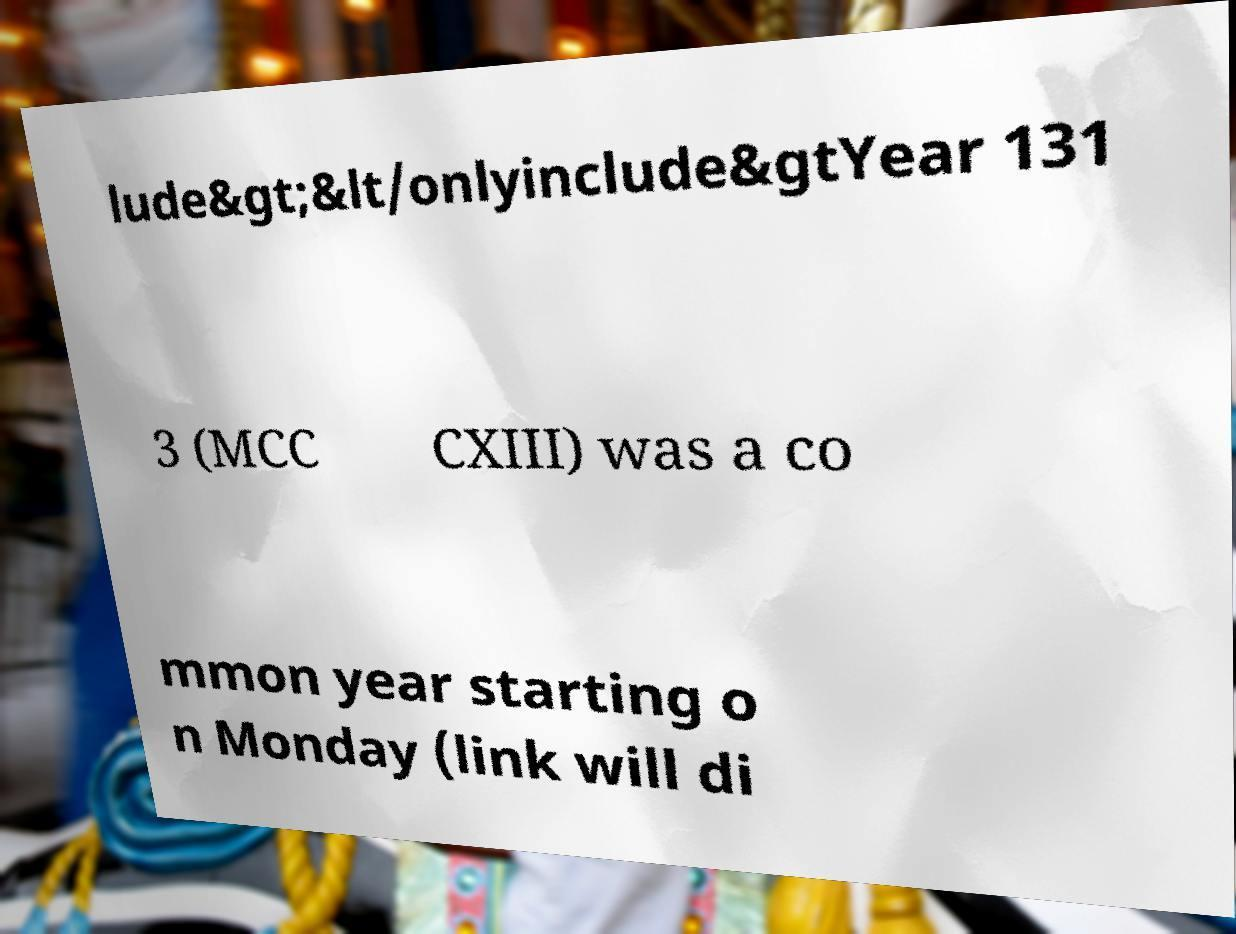Please identify and transcribe the text found in this image. lude&gt;&lt/onlyinclude&gtYear 131 3 (MCC CXIII) was a co mmon year starting o n Monday (link will di 